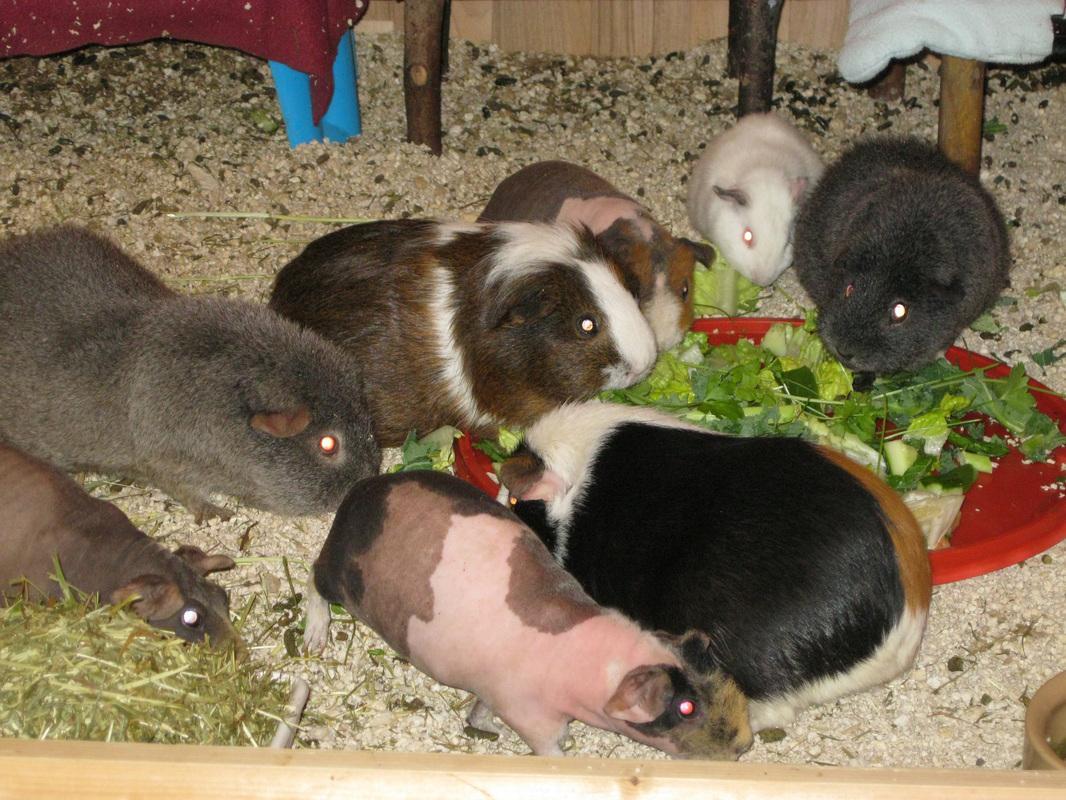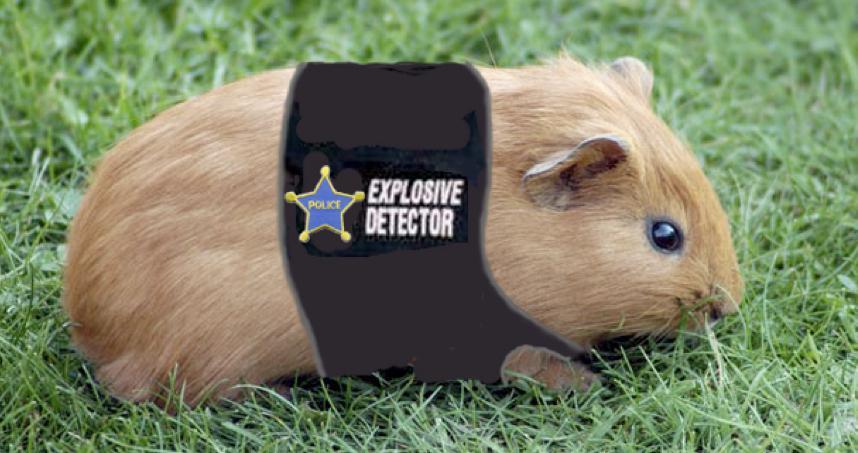The first image is the image on the left, the second image is the image on the right. For the images shown, is this caption "An image features at least five guinea pigs on green grass, and each image contains multiple guinea pigs." true? Answer yes or no. No. The first image is the image on the left, the second image is the image on the right. For the images displayed, is the sentence "One of the images shows multiple guinea pigs on green grass." factually correct? Answer yes or no. No. 